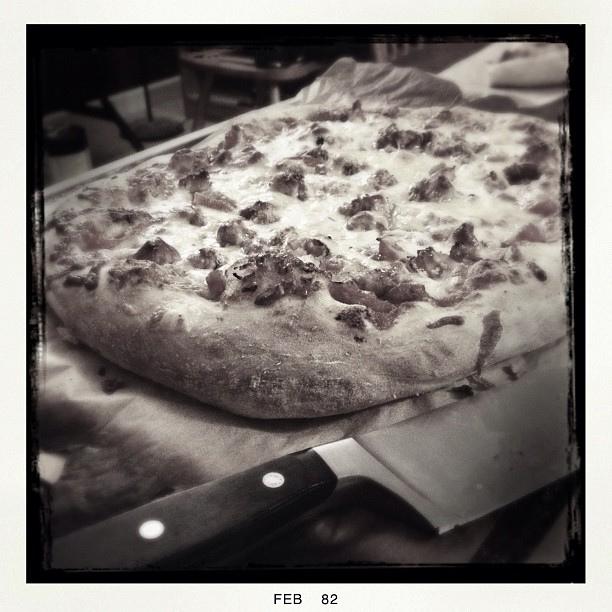What kind of knife is beside the pizza?
Short answer required. Butcher. Is the topping pepperoni?
Write a very short answer. No. What snack is this?
Quick response, please. Pizza. 